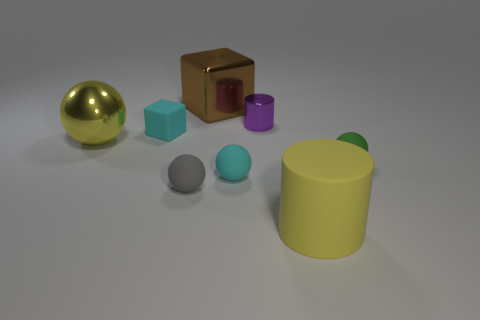Is there any other thing that has the same color as the big cube?
Give a very brief answer. No. There is a ball that is the same color as the tiny block; what is its size?
Your response must be concise. Small. Is there a object that has the same color as the shiny ball?
Offer a very short reply. Yes. Are there any tiny rubber things that are in front of the yellow object that is left of the gray rubber ball?
Make the answer very short. Yes. Are there any big objects that have the same material as the small purple object?
Make the answer very short. Yes. What is the sphere to the left of the small cyan rubber thing on the left side of the cyan matte ball made of?
Your response must be concise. Metal. What material is the big object that is right of the large yellow ball and behind the small green matte ball?
Provide a succinct answer. Metal. Are there an equal number of purple things that are behind the big brown cube and big shiny balls?
Ensure brevity in your answer.  No. What number of big brown matte objects are the same shape as the small green object?
Your answer should be compact. 0. There is a cyan thing behind the small rubber object that is on the right side of the big thing that is in front of the tiny cyan sphere; how big is it?
Your response must be concise. Small. 